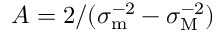Convert formula to latex. <formula><loc_0><loc_0><loc_500><loc_500>A = 2 / ( \sigma _ { m } ^ { - 2 } - \sigma _ { M } ^ { - 2 } )</formula> 